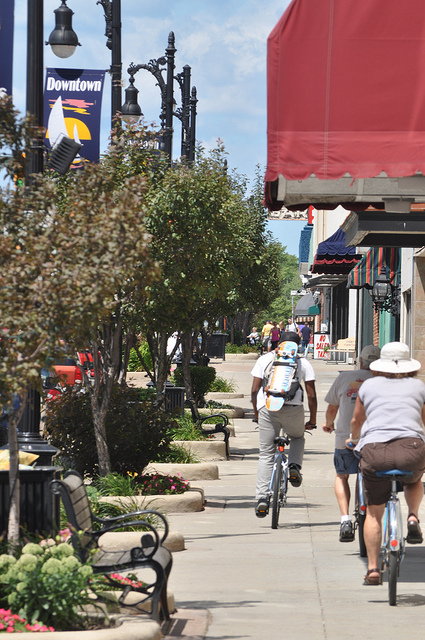Please identify all text content in this image. Downtown 